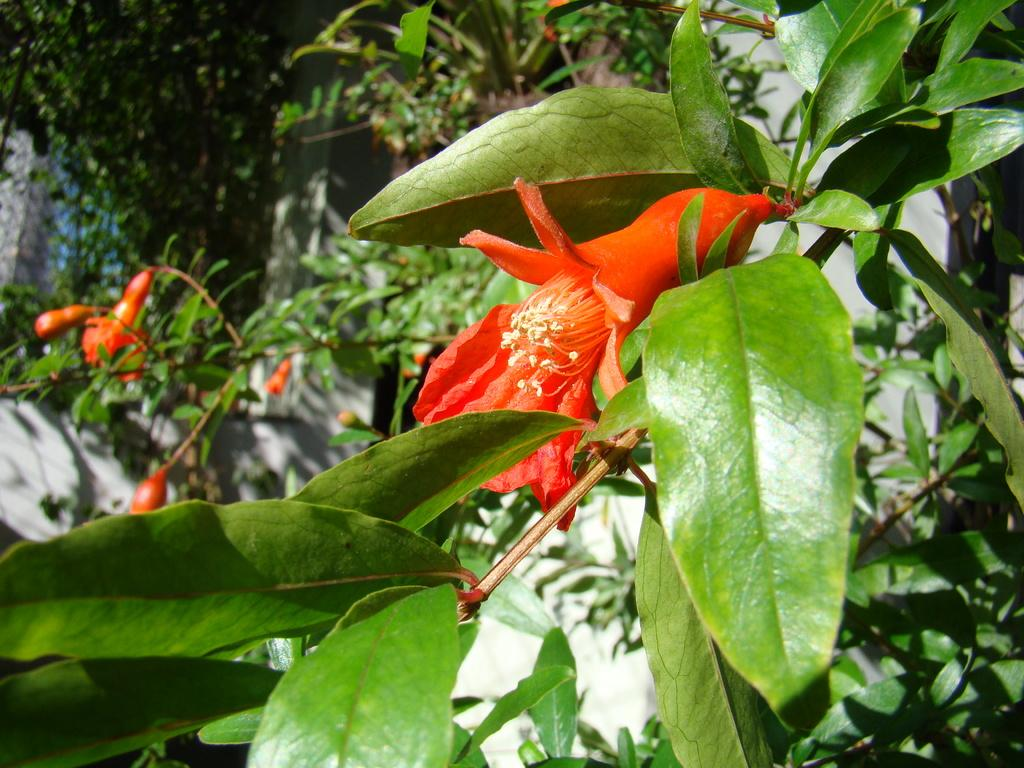What type of tree is in the image? There is a pomegranate tree in the image. What can be seen on the pomegranate tree? The pomegranate tree has flowers. What activity is the yak performing in the image? There is no yak present in the image, so it cannot be performing any activity. 